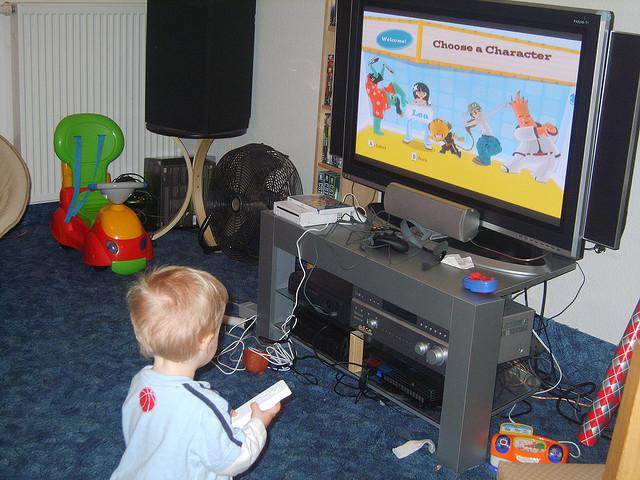Which character has been selected?

Choices:
A) fifth
B) fourth
C) second
D) first second 